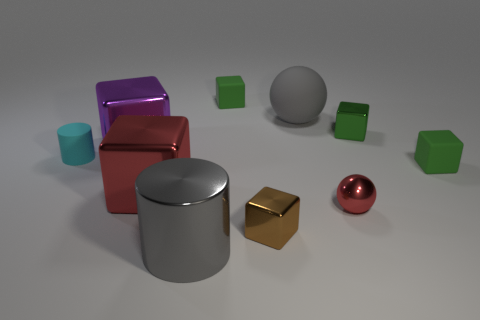Subtract all gray spheres. How many green cubes are left? 3 Subtract all matte blocks. How many blocks are left? 4 Subtract all red cubes. How many cubes are left? 5 Subtract all cyan blocks. Subtract all gray cylinders. How many blocks are left? 6 Subtract all cubes. How many objects are left? 4 Subtract all large red metallic cubes. Subtract all large metal cubes. How many objects are left? 7 Add 6 tiny brown things. How many tiny brown things are left? 7 Add 3 brown cubes. How many brown cubes exist? 4 Subtract 0 blue cylinders. How many objects are left? 10 